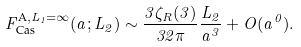Convert formula to latex. <formula><loc_0><loc_0><loc_500><loc_500>F _ { \text {Cas} } ^ { \text {A} , L _ { 1 } = \infty } ( a ; L _ { 2 } ) \sim \frac { 3 \zeta _ { R } ( 3 ) } { 3 2 \pi } \frac { L _ { 2 } } { a ^ { 3 } } + O ( a ^ { 0 } ) .</formula> 